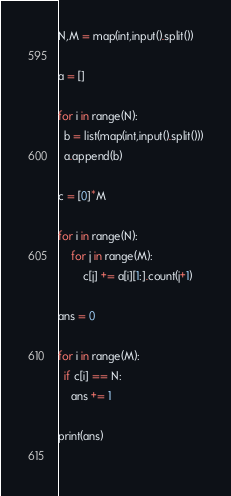<code> <loc_0><loc_0><loc_500><loc_500><_Python_>N,M = map(int,input().split())

a = []

for i in range(N):
  b = list(map(int,input().split()))
  a.append(b)
           
c = [0]*M

for i in range(N):
	for j in range(M):
		c[j] += a[i][1:].count(j+1) 

ans = 0

for i in range(M):
  if c[i] == N:
    ans += 1

print(ans)
  
</code> 